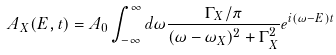Convert formula to latex. <formula><loc_0><loc_0><loc_500><loc_500>A _ { X } ( E , t ) = A _ { 0 } \int _ { - \infty } ^ { \infty } d \omega \frac { \Gamma _ { X } / \pi } { ( \omega - \omega _ { X } ) ^ { 2 } + \Gamma ^ { 2 } _ { X } } e ^ { i ( \omega - E ) t }</formula> 